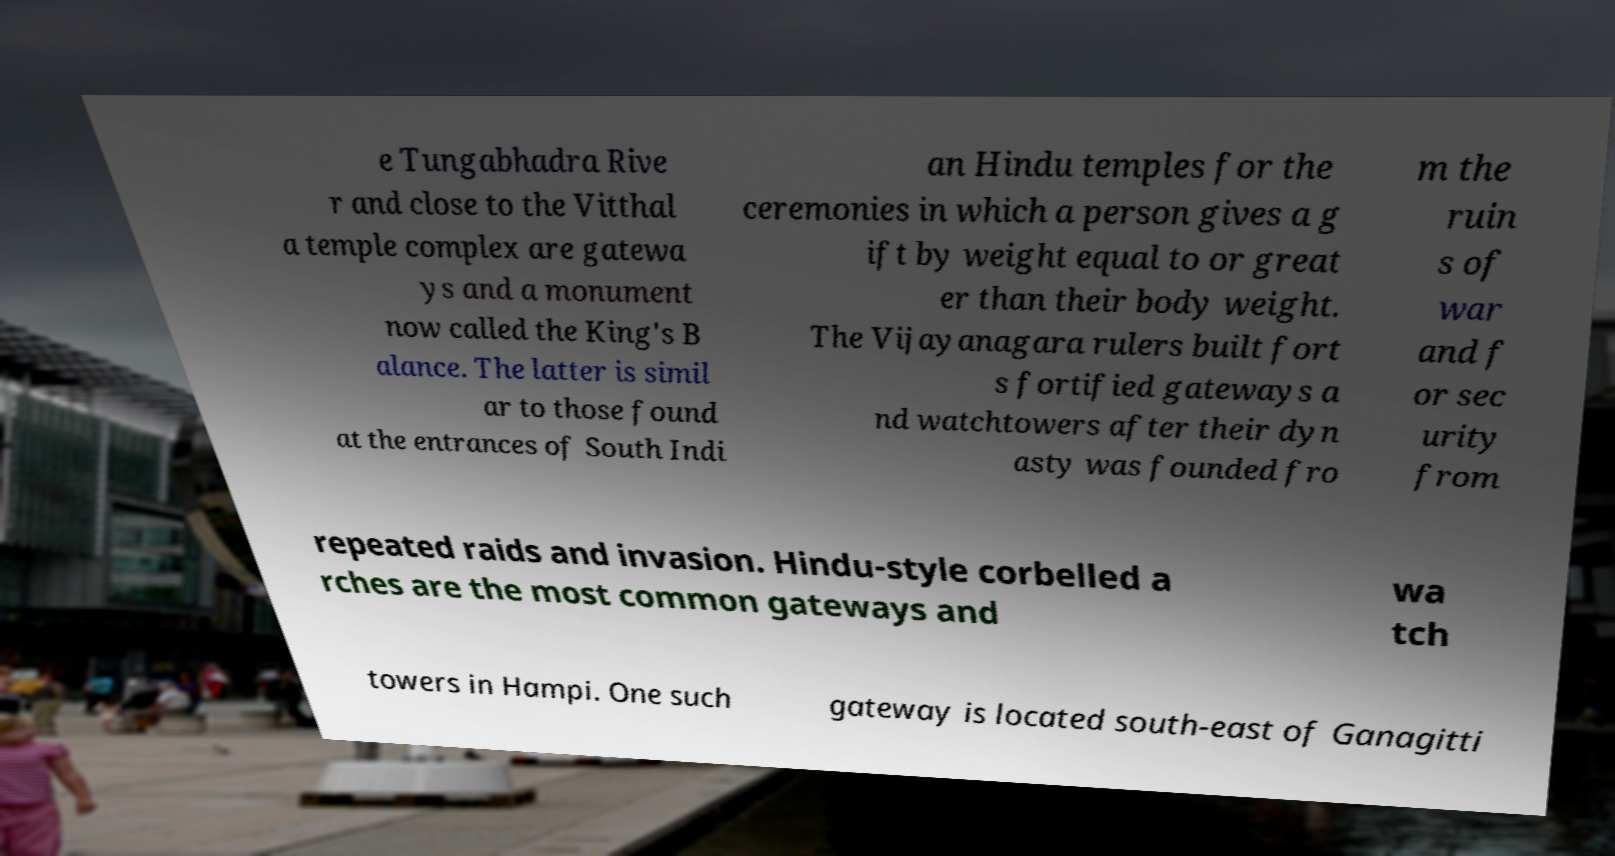I need the written content from this picture converted into text. Can you do that? e Tungabhadra Rive r and close to the Vitthal a temple complex are gatewa ys and a monument now called the King's B alance. The latter is simil ar to those found at the entrances of South Indi an Hindu temples for the ceremonies in which a person gives a g ift by weight equal to or great er than their body weight. The Vijayanagara rulers built fort s fortified gateways a nd watchtowers after their dyn asty was founded fro m the ruin s of war and f or sec urity from repeated raids and invasion. Hindu-style corbelled a rches are the most common gateways and wa tch towers in Hampi. One such gateway is located south-east of Ganagitti 